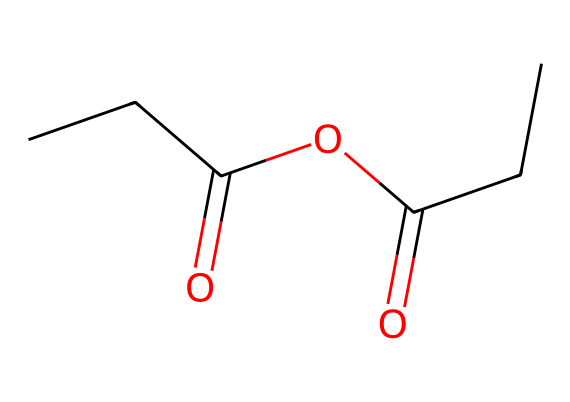What is the molecular formula of propionic anhydride? By analyzing the structure provided in SMILES, we identify the atoms present: 5 carbon (C), 8 hydrogen (H), and 2 oxygen (O). This leads to the molecular formula C5H8O2.
Answer: C5H8O2 How many carbon atoms are in propionic anhydride? In the SMILES representation, we can see that there are 5 carbon atoms represented by 'C' and 'CC' segments. Hence, the total count is 5.
Answer: 5 What type of functional groups are present in propionic anhydride? The structure indicates the presence of an anhydride functional group (C(=O)OC(=O)) and carbonyl groups, which are characteristic of acid anhydrides.
Answer: anhydride What is the degree of unsaturation in propionic anhydride? The formula for calculating degree of unsaturation is U = (2C + 2 + N - H - X)/2. Substituting 5 for C, 0 for N, 8 for H, and 0 for X, we find U = 2. Therefore, it has 2 degrees of unsaturation due to the two carbonyl groups.
Answer: 2 How many oxygen atoms are present in propionic anhydride? In the SMILES structure, we can identify 2 oxygen atoms present (from the C(=O) groups in the anhydride), which means there are a total of 2 oxygen atoms.
Answer: 2 What type of reaction would you use propionic anhydride for? Propionic anhydride is commonly used in acylation reactions, which involve introducing an acyl group into a compound. It's relevant for synthesizing some organic compounds, including fragrances.
Answer: acylation 